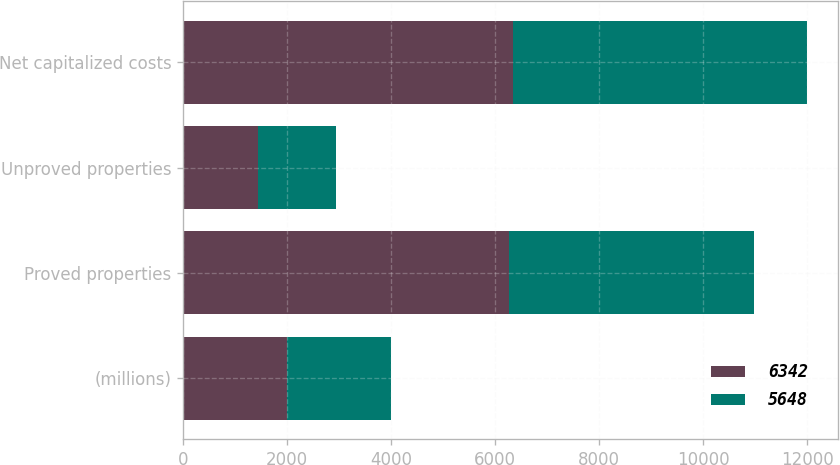Convert chart. <chart><loc_0><loc_0><loc_500><loc_500><stacked_bar_chart><ecel><fcel>(millions)<fcel>Proved properties<fcel>Unproved properties<fcel>Net capitalized costs<nl><fcel>6342<fcel>2002<fcel>6265<fcel>1440<fcel>6342<nl><fcel>5648<fcel>2001<fcel>4707<fcel>1508<fcel>5648<nl></chart> 